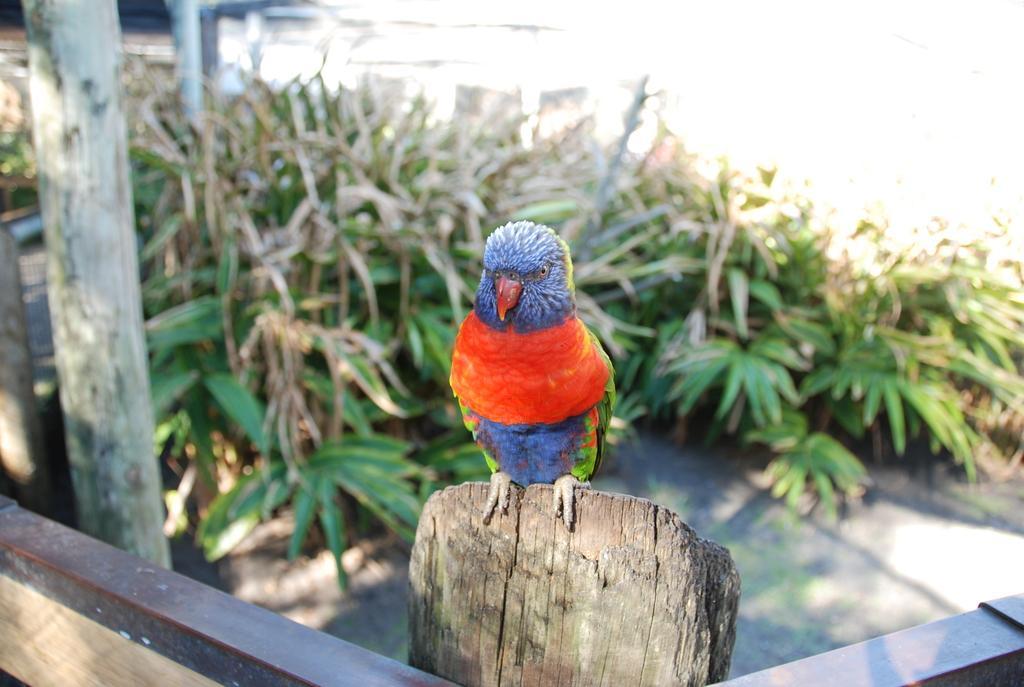Can you describe this image briefly? In this image I can see the bird which is in red, blue and green color. It is on the wooden object. To the left I can see the pole and the plants. I can see the white background. 